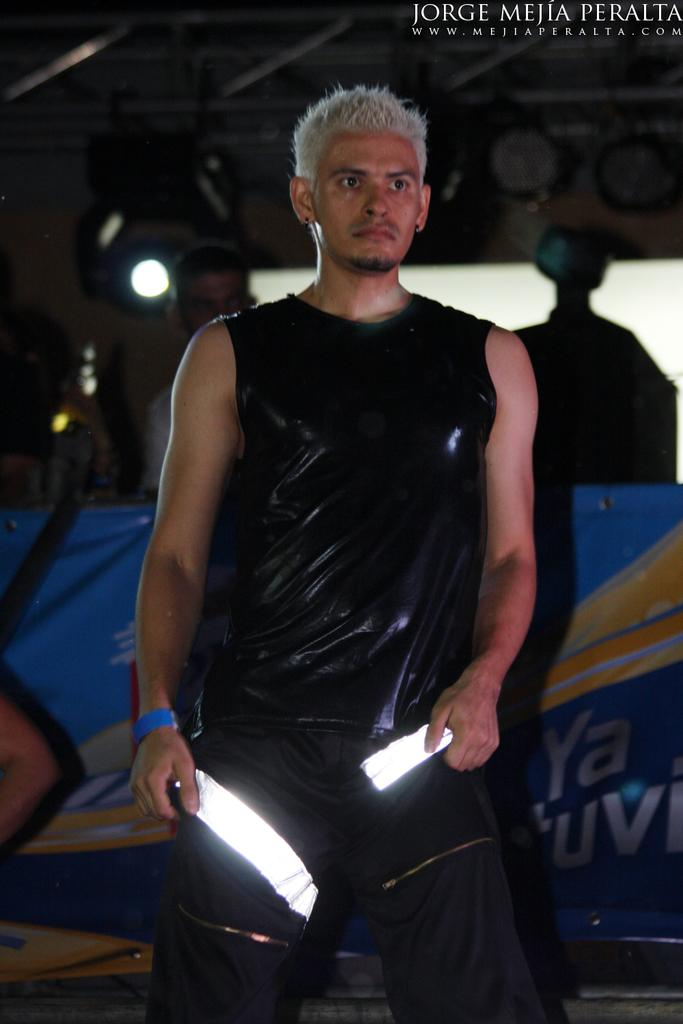<image>
Relay a brief, clear account of the picture shown. A male model strikes a pose in an image created by Jorge Peralta. 